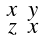Convert formula to latex. <formula><loc_0><loc_0><loc_500><loc_500>\begin{smallmatrix} x & y \\ z & x \end{smallmatrix}</formula> 